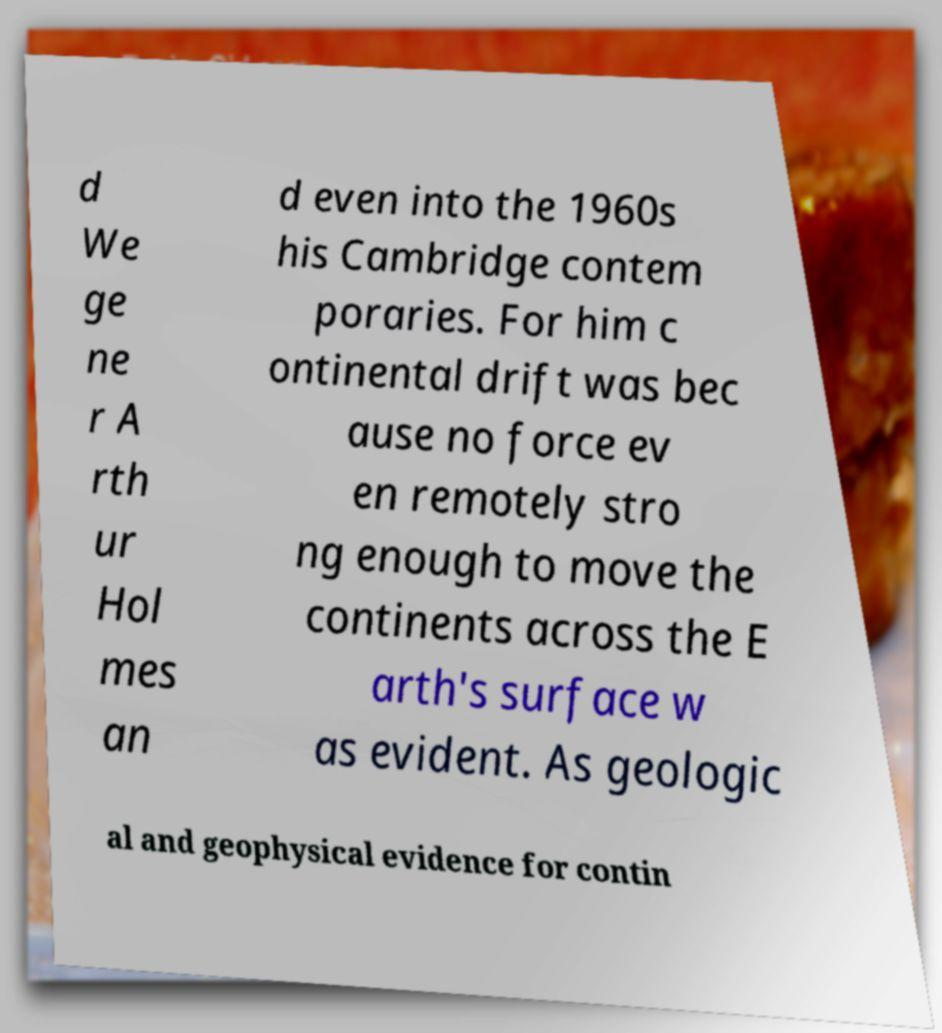I need the written content from this picture converted into text. Can you do that? d We ge ne r A rth ur Hol mes an d even into the 1960s his Cambridge contem poraries. For him c ontinental drift was bec ause no force ev en remotely stro ng enough to move the continents across the E arth's surface w as evident. As geologic al and geophysical evidence for contin 